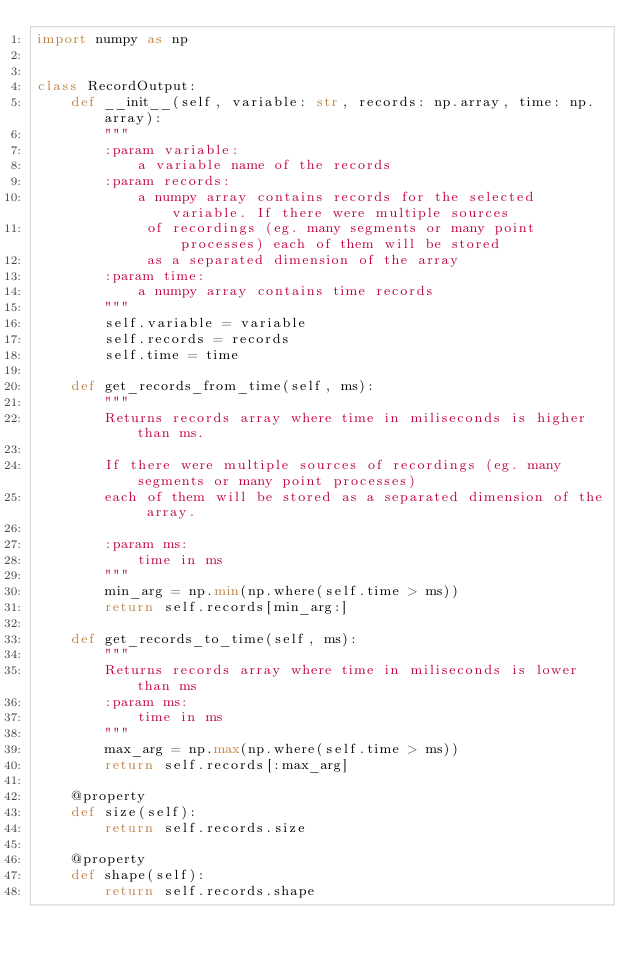Convert code to text. <code><loc_0><loc_0><loc_500><loc_500><_Python_>import numpy as np


class RecordOutput:
    def __init__(self, variable: str, records: np.array, time: np.array):
        """
        :param variable:
            a variable name of the records
        :param records:
            a numpy array contains records for the selected variable. If there were multiple sources
             of recordings (eg. many segments or many point processes) each of them will be stored
             as a separated dimension of the array
        :param time:
            a numpy array contains time records
        """
        self.variable = variable
        self.records = records
        self.time = time

    def get_records_from_time(self, ms):
        """
        Returns records array where time in miliseconds is higher than ms.

        If there were multiple sources of recordings (eg. many segments or many point processes)
        each of them will be stored as a separated dimension of the array.

        :param ms:
            time in ms
        """
        min_arg = np.min(np.where(self.time > ms))
        return self.records[min_arg:]

    def get_records_to_time(self, ms):
        """
        Returns records array where time in miliseconds is lower than ms
        :param ms:
            time in ms
        """
        max_arg = np.max(np.where(self.time > ms))
        return self.records[:max_arg]

    @property
    def size(self):
        return self.records.size

    @property
    def shape(self):
        return self.records.shape
</code> 